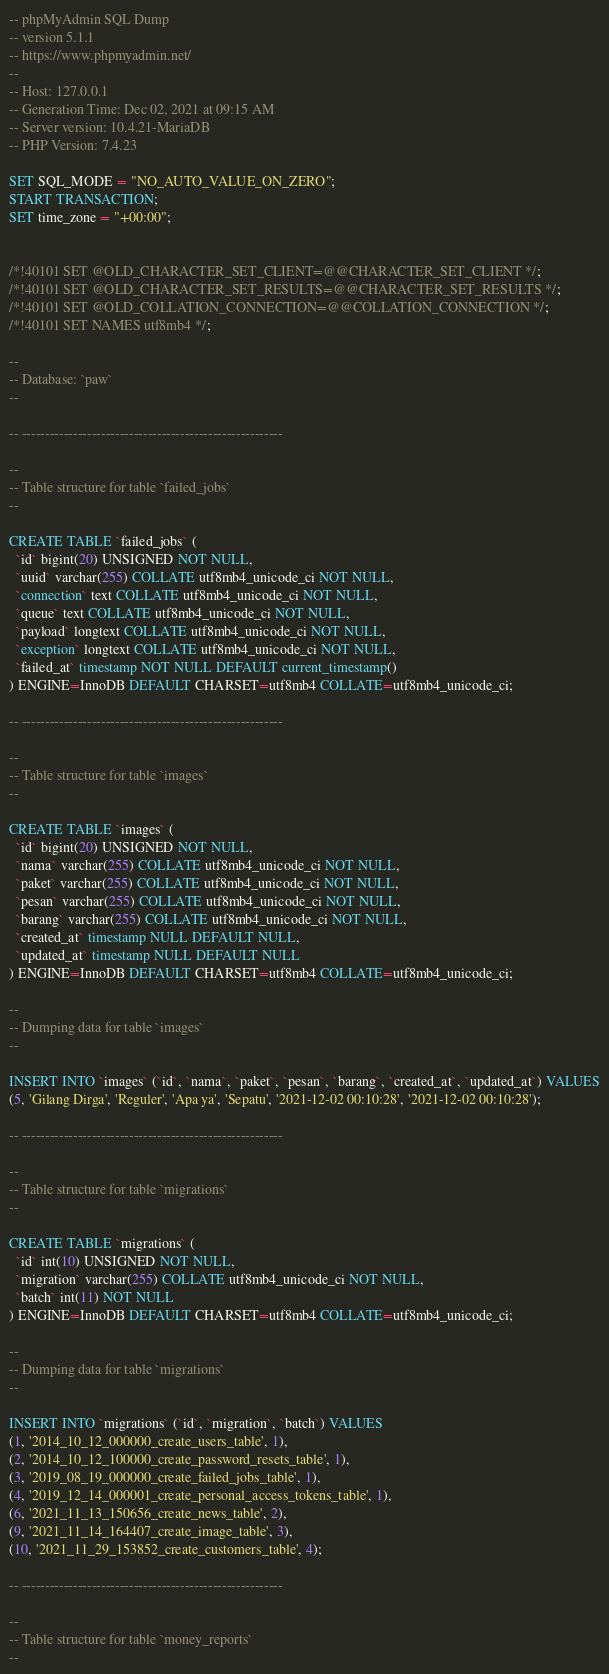<code> <loc_0><loc_0><loc_500><loc_500><_SQL_>-- phpMyAdmin SQL Dump
-- version 5.1.1
-- https://www.phpmyadmin.net/
--
-- Host: 127.0.0.1
-- Generation Time: Dec 02, 2021 at 09:15 AM
-- Server version: 10.4.21-MariaDB
-- PHP Version: 7.4.23

SET SQL_MODE = "NO_AUTO_VALUE_ON_ZERO";
START TRANSACTION;
SET time_zone = "+00:00";


/*!40101 SET @OLD_CHARACTER_SET_CLIENT=@@CHARACTER_SET_CLIENT */;
/*!40101 SET @OLD_CHARACTER_SET_RESULTS=@@CHARACTER_SET_RESULTS */;
/*!40101 SET @OLD_COLLATION_CONNECTION=@@COLLATION_CONNECTION */;
/*!40101 SET NAMES utf8mb4 */;

--
-- Database: `paw`
--

-- --------------------------------------------------------

--
-- Table structure for table `failed_jobs`
--

CREATE TABLE `failed_jobs` (
  `id` bigint(20) UNSIGNED NOT NULL,
  `uuid` varchar(255) COLLATE utf8mb4_unicode_ci NOT NULL,
  `connection` text COLLATE utf8mb4_unicode_ci NOT NULL,
  `queue` text COLLATE utf8mb4_unicode_ci NOT NULL,
  `payload` longtext COLLATE utf8mb4_unicode_ci NOT NULL,
  `exception` longtext COLLATE utf8mb4_unicode_ci NOT NULL,
  `failed_at` timestamp NOT NULL DEFAULT current_timestamp()
) ENGINE=InnoDB DEFAULT CHARSET=utf8mb4 COLLATE=utf8mb4_unicode_ci;

-- --------------------------------------------------------

--
-- Table structure for table `images`
--

CREATE TABLE `images` (
  `id` bigint(20) UNSIGNED NOT NULL,
  `nama` varchar(255) COLLATE utf8mb4_unicode_ci NOT NULL,
  `paket` varchar(255) COLLATE utf8mb4_unicode_ci NOT NULL,
  `pesan` varchar(255) COLLATE utf8mb4_unicode_ci NOT NULL,
  `barang` varchar(255) COLLATE utf8mb4_unicode_ci NOT NULL,
  `created_at` timestamp NULL DEFAULT NULL,
  `updated_at` timestamp NULL DEFAULT NULL
) ENGINE=InnoDB DEFAULT CHARSET=utf8mb4 COLLATE=utf8mb4_unicode_ci;

--
-- Dumping data for table `images`
--

INSERT INTO `images` (`id`, `nama`, `paket`, `pesan`, `barang`, `created_at`, `updated_at`) VALUES
(5, 'Gilang Dirga', 'Reguler', 'Apa ya', 'Sepatu', '2021-12-02 00:10:28', '2021-12-02 00:10:28');

-- --------------------------------------------------------

--
-- Table structure for table `migrations`
--

CREATE TABLE `migrations` (
  `id` int(10) UNSIGNED NOT NULL,
  `migration` varchar(255) COLLATE utf8mb4_unicode_ci NOT NULL,
  `batch` int(11) NOT NULL
) ENGINE=InnoDB DEFAULT CHARSET=utf8mb4 COLLATE=utf8mb4_unicode_ci;

--
-- Dumping data for table `migrations`
--

INSERT INTO `migrations` (`id`, `migration`, `batch`) VALUES
(1, '2014_10_12_000000_create_users_table', 1),
(2, '2014_10_12_100000_create_password_resets_table', 1),
(3, '2019_08_19_000000_create_failed_jobs_table', 1),
(4, '2019_12_14_000001_create_personal_access_tokens_table', 1),
(6, '2021_11_13_150656_create_news_table', 2),
(9, '2021_11_14_164407_create_image_table', 3),
(10, '2021_11_29_153852_create_customers_table', 4);

-- --------------------------------------------------------

--
-- Table structure for table `money_reports`
--
</code> 